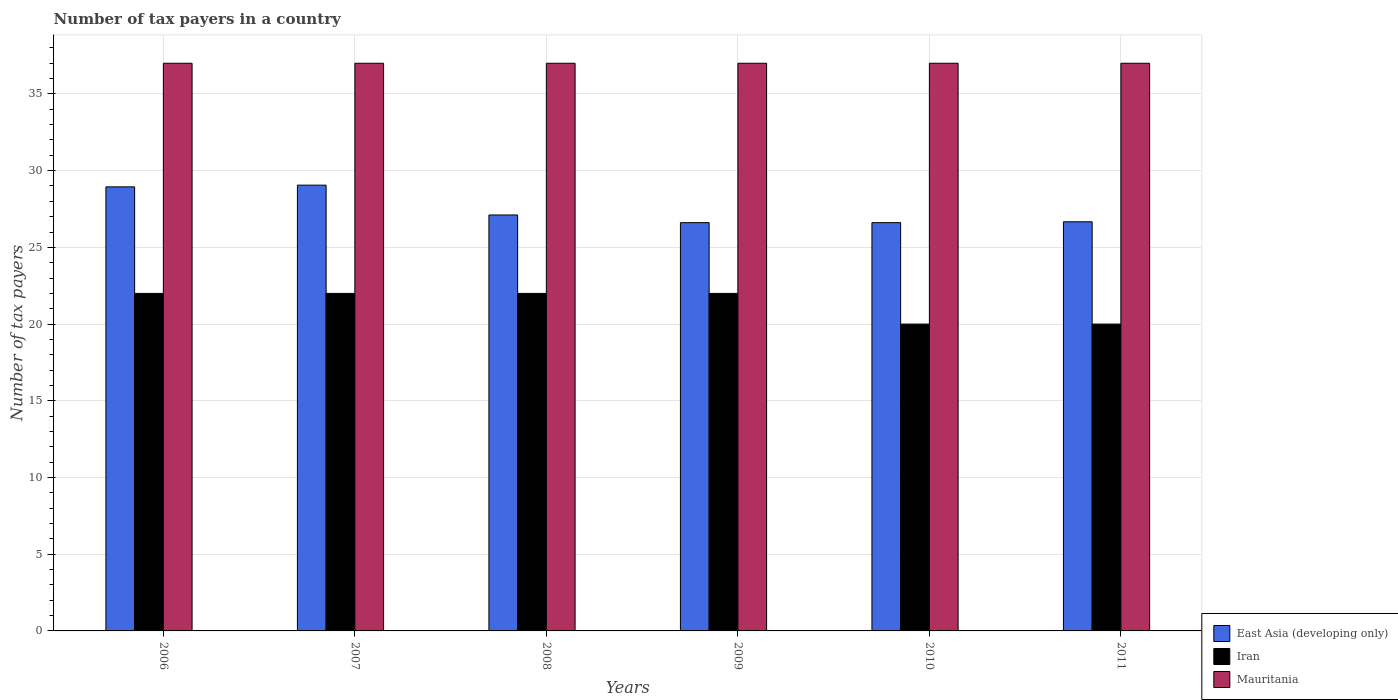How many groups of bars are there?
Ensure brevity in your answer.  6. How many bars are there on the 6th tick from the left?
Your answer should be compact. 3. How many bars are there on the 1st tick from the right?
Keep it short and to the point. 3. What is the label of the 1st group of bars from the left?
Your answer should be very brief. 2006. In how many cases, is the number of bars for a given year not equal to the number of legend labels?
Ensure brevity in your answer.  0. What is the number of tax payers in in Mauritania in 2006?
Offer a very short reply. 37. Across all years, what is the maximum number of tax payers in in East Asia (developing only)?
Offer a very short reply. 29.06. Across all years, what is the minimum number of tax payers in in Mauritania?
Your response must be concise. 37. In which year was the number of tax payers in in Mauritania minimum?
Make the answer very short. 2006. What is the total number of tax payers in in Mauritania in the graph?
Offer a very short reply. 222. What is the difference between the number of tax payers in in Iran in 2006 and that in 2010?
Provide a short and direct response. 2. What is the difference between the number of tax payers in in Iran in 2007 and the number of tax payers in in East Asia (developing only) in 2010?
Offer a terse response. -4.61. What is the average number of tax payers in in East Asia (developing only) per year?
Offer a terse response. 27.5. In the year 2006, what is the difference between the number of tax payers in in Iran and number of tax payers in in East Asia (developing only)?
Your answer should be very brief. -6.94. In how many years, is the number of tax payers in in Mauritania greater than 3?
Your response must be concise. 6. What is the ratio of the number of tax payers in in Mauritania in 2006 to that in 2011?
Your answer should be very brief. 1. Is the number of tax payers in in Mauritania in 2006 less than that in 2009?
Ensure brevity in your answer.  No. Is the difference between the number of tax payers in in Iran in 2009 and 2011 greater than the difference between the number of tax payers in in East Asia (developing only) in 2009 and 2011?
Provide a short and direct response. Yes. What is the difference between the highest and the second highest number of tax payers in in Iran?
Your answer should be very brief. 0. What is the difference between the highest and the lowest number of tax payers in in East Asia (developing only)?
Provide a succinct answer. 2.44. In how many years, is the number of tax payers in in Mauritania greater than the average number of tax payers in in Mauritania taken over all years?
Provide a short and direct response. 0. Is the sum of the number of tax payers in in East Asia (developing only) in 2006 and 2010 greater than the maximum number of tax payers in in Mauritania across all years?
Ensure brevity in your answer.  Yes. What does the 1st bar from the left in 2007 represents?
Offer a very short reply. East Asia (developing only). What does the 1st bar from the right in 2011 represents?
Give a very brief answer. Mauritania. Is it the case that in every year, the sum of the number of tax payers in in Iran and number of tax payers in in Mauritania is greater than the number of tax payers in in East Asia (developing only)?
Provide a short and direct response. Yes. How many bars are there?
Your answer should be compact. 18. What is the difference between two consecutive major ticks on the Y-axis?
Ensure brevity in your answer.  5. Does the graph contain any zero values?
Give a very brief answer. No. How are the legend labels stacked?
Ensure brevity in your answer.  Vertical. What is the title of the graph?
Ensure brevity in your answer.  Number of tax payers in a country. Does "Grenada" appear as one of the legend labels in the graph?
Your answer should be compact. No. What is the label or title of the X-axis?
Make the answer very short. Years. What is the label or title of the Y-axis?
Make the answer very short. Number of tax payers. What is the Number of tax payers in East Asia (developing only) in 2006?
Give a very brief answer. 28.94. What is the Number of tax payers of East Asia (developing only) in 2007?
Your response must be concise. 29.06. What is the Number of tax payers in Iran in 2007?
Offer a very short reply. 22. What is the Number of tax payers of Mauritania in 2007?
Offer a very short reply. 37. What is the Number of tax payers of East Asia (developing only) in 2008?
Keep it short and to the point. 27.11. What is the Number of tax payers in Mauritania in 2008?
Your answer should be very brief. 37. What is the Number of tax payers of East Asia (developing only) in 2009?
Provide a short and direct response. 26.61. What is the Number of tax payers in Iran in 2009?
Offer a very short reply. 22. What is the Number of tax payers of East Asia (developing only) in 2010?
Your answer should be very brief. 26.61. What is the Number of tax payers of East Asia (developing only) in 2011?
Offer a terse response. 26.67. What is the Number of tax payers of Mauritania in 2011?
Keep it short and to the point. 37. Across all years, what is the maximum Number of tax payers in East Asia (developing only)?
Provide a short and direct response. 29.06. Across all years, what is the minimum Number of tax payers in East Asia (developing only)?
Ensure brevity in your answer.  26.61. Across all years, what is the minimum Number of tax payers in Iran?
Ensure brevity in your answer.  20. Across all years, what is the minimum Number of tax payers of Mauritania?
Provide a succinct answer. 37. What is the total Number of tax payers of East Asia (developing only) in the graph?
Your answer should be compact. 165. What is the total Number of tax payers of Iran in the graph?
Offer a very short reply. 128. What is the total Number of tax payers of Mauritania in the graph?
Offer a terse response. 222. What is the difference between the Number of tax payers in East Asia (developing only) in 2006 and that in 2007?
Your response must be concise. -0.11. What is the difference between the Number of tax payers in Mauritania in 2006 and that in 2007?
Give a very brief answer. 0. What is the difference between the Number of tax payers of East Asia (developing only) in 2006 and that in 2008?
Ensure brevity in your answer.  1.83. What is the difference between the Number of tax payers of Iran in 2006 and that in 2008?
Make the answer very short. 0. What is the difference between the Number of tax payers in Mauritania in 2006 and that in 2008?
Offer a terse response. 0. What is the difference between the Number of tax payers of East Asia (developing only) in 2006 and that in 2009?
Offer a very short reply. 2.33. What is the difference between the Number of tax payers in Mauritania in 2006 and that in 2009?
Offer a terse response. 0. What is the difference between the Number of tax payers in East Asia (developing only) in 2006 and that in 2010?
Keep it short and to the point. 2.33. What is the difference between the Number of tax payers in East Asia (developing only) in 2006 and that in 2011?
Provide a succinct answer. 2.28. What is the difference between the Number of tax payers of East Asia (developing only) in 2007 and that in 2008?
Your response must be concise. 1.94. What is the difference between the Number of tax payers of Iran in 2007 and that in 2008?
Make the answer very short. 0. What is the difference between the Number of tax payers in East Asia (developing only) in 2007 and that in 2009?
Give a very brief answer. 2.44. What is the difference between the Number of tax payers in Iran in 2007 and that in 2009?
Your response must be concise. 0. What is the difference between the Number of tax payers in East Asia (developing only) in 2007 and that in 2010?
Provide a short and direct response. 2.44. What is the difference between the Number of tax payers of Iran in 2007 and that in 2010?
Your answer should be very brief. 2. What is the difference between the Number of tax payers in Mauritania in 2007 and that in 2010?
Keep it short and to the point. 0. What is the difference between the Number of tax payers in East Asia (developing only) in 2007 and that in 2011?
Provide a short and direct response. 2.39. What is the difference between the Number of tax payers in Mauritania in 2008 and that in 2009?
Your answer should be compact. 0. What is the difference between the Number of tax payers of East Asia (developing only) in 2008 and that in 2010?
Offer a very short reply. 0.5. What is the difference between the Number of tax payers of Mauritania in 2008 and that in 2010?
Your answer should be compact. 0. What is the difference between the Number of tax payers of East Asia (developing only) in 2008 and that in 2011?
Offer a terse response. 0.44. What is the difference between the Number of tax payers of Iran in 2008 and that in 2011?
Your answer should be compact. 2. What is the difference between the Number of tax payers of Mauritania in 2008 and that in 2011?
Keep it short and to the point. 0. What is the difference between the Number of tax payers in East Asia (developing only) in 2009 and that in 2011?
Keep it short and to the point. -0.06. What is the difference between the Number of tax payers of Iran in 2009 and that in 2011?
Provide a succinct answer. 2. What is the difference between the Number of tax payers of East Asia (developing only) in 2010 and that in 2011?
Make the answer very short. -0.06. What is the difference between the Number of tax payers in Iran in 2010 and that in 2011?
Your answer should be very brief. 0. What is the difference between the Number of tax payers of East Asia (developing only) in 2006 and the Number of tax payers of Iran in 2007?
Provide a succinct answer. 6.94. What is the difference between the Number of tax payers in East Asia (developing only) in 2006 and the Number of tax payers in Mauritania in 2007?
Give a very brief answer. -8.06. What is the difference between the Number of tax payers in East Asia (developing only) in 2006 and the Number of tax payers in Iran in 2008?
Offer a very short reply. 6.94. What is the difference between the Number of tax payers of East Asia (developing only) in 2006 and the Number of tax payers of Mauritania in 2008?
Ensure brevity in your answer.  -8.06. What is the difference between the Number of tax payers of Iran in 2006 and the Number of tax payers of Mauritania in 2008?
Give a very brief answer. -15. What is the difference between the Number of tax payers in East Asia (developing only) in 2006 and the Number of tax payers in Iran in 2009?
Your answer should be compact. 6.94. What is the difference between the Number of tax payers of East Asia (developing only) in 2006 and the Number of tax payers of Mauritania in 2009?
Give a very brief answer. -8.06. What is the difference between the Number of tax payers of Iran in 2006 and the Number of tax payers of Mauritania in 2009?
Keep it short and to the point. -15. What is the difference between the Number of tax payers of East Asia (developing only) in 2006 and the Number of tax payers of Iran in 2010?
Provide a succinct answer. 8.94. What is the difference between the Number of tax payers of East Asia (developing only) in 2006 and the Number of tax payers of Mauritania in 2010?
Offer a very short reply. -8.06. What is the difference between the Number of tax payers in Iran in 2006 and the Number of tax payers in Mauritania in 2010?
Give a very brief answer. -15. What is the difference between the Number of tax payers of East Asia (developing only) in 2006 and the Number of tax payers of Iran in 2011?
Your answer should be very brief. 8.94. What is the difference between the Number of tax payers in East Asia (developing only) in 2006 and the Number of tax payers in Mauritania in 2011?
Give a very brief answer. -8.06. What is the difference between the Number of tax payers of East Asia (developing only) in 2007 and the Number of tax payers of Iran in 2008?
Your answer should be very brief. 7.06. What is the difference between the Number of tax payers of East Asia (developing only) in 2007 and the Number of tax payers of Mauritania in 2008?
Make the answer very short. -7.94. What is the difference between the Number of tax payers of Iran in 2007 and the Number of tax payers of Mauritania in 2008?
Ensure brevity in your answer.  -15. What is the difference between the Number of tax payers in East Asia (developing only) in 2007 and the Number of tax payers in Iran in 2009?
Provide a short and direct response. 7.06. What is the difference between the Number of tax payers of East Asia (developing only) in 2007 and the Number of tax payers of Mauritania in 2009?
Ensure brevity in your answer.  -7.94. What is the difference between the Number of tax payers of Iran in 2007 and the Number of tax payers of Mauritania in 2009?
Offer a terse response. -15. What is the difference between the Number of tax payers of East Asia (developing only) in 2007 and the Number of tax payers of Iran in 2010?
Your response must be concise. 9.06. What is the difference between the Number of tax payers of East Asia (developing only) in 2007 and the Number of tax payers of Mauritania in 2010?
Provide a short and direct response. -7.94. What is the difference between the Number of tax payers in Iran in 2007 and the Number of tax payers in Mauritania in 2010?
Make the answer very short. -15. What is the difference between the Number of tax payers of East Asia (developing only) in 2007 and the Number of tax payers of Iran in 2011?
Make the answer very short. 9.06. What is the difference between the Number of tax payers in East Asia (developing only) in 2007 and the Number of tax payers in Mauritania in 2011?
Offer a very short reply. -7.94. What is the difference between the Number of tax payers of East Asia (developing only) in 2008 and the Number of tax payers of Iran in 2009?
Offer a very short reply. 5.11. What is the difference between the Number of tax payers in East Asia (developing only) in 2008 and the Number of tax payers in Mauritania in 2009?
Offer a very short reply. -9.89. What is the difference between the Number of tax payers of East Asia (developing only) in 2008 and the Number of tax payers of Iran in 2010?
Keep it short and to the point. 7.11. What is the difference between the Number of tax payers of East Asia (developing only) in 2008 and the Number of tax payers of Mauritania in 2010?
Your answer should be very brief. -9.89. What is the difference between the Number of tax payers in Iran in 2008 and the Number of tax payers in Mauritania in 2010?
Give a very brief answer. -15. What is the difference between the Number of tax payers in East Asia (developing only) in 2008 and the Number of tax payers in Iran in 2011?
Provide a succinct answer. 7.11. What is the difference between the Number of tax payers in East Asia (developing only) in 2008 and the Number of tax payers in Mauritania in 2011?
Ensure brevity in your answer.  -9.89. What is the difference between the Number of tax payers in Iran in 2008 and the Number of tax payers in Mauritania in 2011?
Provide a short and direct response. -15. What is the difference between the Number of tax payers of East Asia (developing only) in 2009 and the Number of tax payers of Iran in 2010?
Provide a succinct answer. 6.61. What is the difference between the Number of tax payers in East Asia (developing only) in 2009 and the Number of tax payers in Mauritania in 2010?
Give a very brief answer. -10.39. What is the difference between the Number of tax payers in Iran in 2009 and the Number of tax payers in Mauritania in 2010?
Keep it short and to the point. -15. What is the difference between the Number of tax payers of East Asia (developing only) in 2009 and the Number of tax payers of Iran in 2011?
Give a very brief answer. 6.61. What is the difference between the Number of tax payers of East Asia (developing only) in 2009 and the Number of tax payers of Mauritania in 2011?
Make the answer very short. -10.39. What is the difference between the Number of tax payers of Iran in 2009 and the Number of tax payers of Mauritania in 2011?
Your answer should be very brief. -15. What is the difference between the Number of tax payers in East Asia (developing only) in 2010 and the Number of tax payers in Iran in 2011?
Give a very brief answer. 6.61. What is the difference between the Number of tax payers in East Asia (developing only) in 2010 and the Number of tax payers in Mauritania in 2011?
Ensure brevity in your answer.  -10.39. What is the average Number of tax payers of Iran per year?
Your answer should be very brief. 21.33. What is the average Number of tax payers of Mauritania per year?
Provide a succinct answer. 37. In the year 2006, what is the difference between the Number of tax payers of East Asia (developing only) and Number of tax payers of Iran?
Make the answer very short. 6.94. In the year 2006, what is the difference between the Number of tax payers in East Asia (developing only) and Number of tax payers in Mauritania?
Give a very brief answer. -8.06. In the year 2006, what is the difference between the Number of tax payers of Iran and Number of tax payers of Mauritania?
Offer a very short reply. -15. In the year 2007, what is the difference between the Number of tax payers in East Asia (developing only) and Number of tax payers in Iran?
Keep it short and to the point. 7.06. In the year 2007, what is the difference between the Number of tax payers of East Asia (developing only) and Number of tax payers of Mauritania?
Offer a terse response. -7.94. In the year 2008, what is the difference between the Number of tax payers of East Asia (developing only) and Number of tax payers of Iran?
Offer a very short reply. 5.11. In the year 2008, what is the difference between the Number of tax payers in East Asia (developing only) and Number of tax payers in Mauritania?
Ensure brevity in your answer.  -9.89. In the year 2009, what is the difference between the Number of tax payers in East Asia (developing only) and Number of tax payers in Iran?
Your response must be concise. 4.61. In the year 2009, what is the difference between the Number of tax payers of East Asia (developing only) and Number of tax payers of Mauritania?
Offer a terse response. -10.39. In the year 2009, what is the difference between the Number of tax payers of Iran and Number of tax payers of Mauritania?
Make the answer very short. -15. In the year 2010, what is the difference between the Number of tax payers of East Asia (developing only) and Number of tax payers of Iran?
Keep it short and to the point. 6.61. In the year 2010, what is the difference between the Number of tax payers of East Asia (developing only) and Number of tax payers of Mauritania?
Your response must be concise. -10.39. In the year 2010, what is the difference between the Number of tax payers of Iran and Number of tax payers of Mauritania?
Keep it short and to the point. -17. In the year 2011, what is the difference between the Number of tax payers of East Asia (developing only) and Number of tax payers of Iran?
Ensure brevity in your answer.  6.67. In the year 2011, what is the difference between the Number of tax payers in East Asia (developing only) and Number of tax payers in Mauritania?
Provide a succinct answer. -10.33. In the year 2011, what is the difference between the Number of tax payers in Iran and Number of tax payers in Mauritania?
Offer a very short reply. -17. What is the ratio of the Number of tax payers in East Asia (developing only) in 2006 to that in 2007?
Offer a terse response. 1. What is the ratio of the Number of tax payers in Iran in 2006 to that in 2007?
Provide a short and direct response. 1. What is the ratio of the Number of tax payers in East Asia (developing only) in 2006 to that in 2008?
Provide a short and direct response. 1.07. What is the ratio of the Number of tax payers of Iran in 2006 to that in 2008?
Offer a very short reply. 1. What is the ratio of the Number of tax payers of Mauritania in 2006 to that in 2008?
Offer a very short reply. 1. What is the ratio of the Number of tax payers in East Asia (developing only) in 2006 to that in 2009?
Your answer should be compact. 1.09. What is the ratio of the Number of tax payers in Mauritania in 2006 to that in 2009?
Offer a very short reply. 1. What is the ratio of the Number of tax payers of East Asia (developing only) in 2006 to that in 2010?
Offer a very short reply. 1.09. What is the ratio of the Number of tax payers in Iran in 2006 to that in 2010?
Offer a terse response. 1.1. What is the ratio of the Number of tax payers in East Asia (developing only) in 2006 to that in 2011?
Offer a terse response. 1.09. What is the ratio of the Number of tax payers in Iran in 2006 to that in 2011?
Make the answer very short. 1.1. What is the ratio of the Number of tax payers of Mauritania in 2006 to that in 2011?
Keep it short and to the point. 1. What is the ratio of the Number of tax payers in East Asia (developing only) in 2007 to that in 2008?
Give a very brief answer. 1.07. What is the ratio of the Number of tax payers of Iran in 2007 to that in 2008?
Give a very brief answer. 1. What is the ratio of the Number of tax payers of East Asia (developing only) in 2007 to that in 2009?
Offer a terse response. 1.09. What is the ratio of the Number of tax payers in Mauritania in 2007 to that in 2009?
Provide a succinct answer. 1. What is the ratio of the Number of tax payers in East Asia (developing only) in 2007 to that in 2010?
Keep it short and to the point. 1.09. What is the ratio of the Number of tax payers in Iran in 2007 to that in 2010?
Give a very brief answer. 1.1. What is the ratio of the Number of tax payers of East Asia (developing only) in 2007 to that in 2011?
Your response must be concise. 1.09. What is the ratio of the Number of tax payers in Iran in 2007 to that in 2011?
Ensure brevity in your answer.  1.1. What is the ratio of the Number of tax payers in East Asia (developing only) in 2008 to that in 2009?
Provide a short and direct response. 1.02. What is the ratio of the Number of tax payers of East Asia (developing only) in 2008 to that in 2010?
Make the answer very short. 1.02. What is the ratio of the Number of tax payers in Mauritania in 2008 to that in 2010?
Offer a terse response. 1. What is the ratio of the Number of tax payers of East Asia (developing only) in 2008 to that in 2011?
Provide a short and direct response. 1.02. What is the ratio of the Number of tax payers in Iran in 2008 to that in 2011?
Your answer should be very brief. 1.1. What is the ratio of the Number of tax payers of East Asia (developing only) in 2009 to that in 2010?
Provide a succinct answer. 1. What is the ratio of the Number of tax payers of Iran in 2009 to that in 2010?
Provide a short and direct response. 1.1. What is the ratio of the Number of tax payers of East Asia (developing only) in 2009 to that in 2011?
Offer a terse response. 1. What is the ratio of the Number of tax payers of East Asia (developing only) in 2010 to that in 2011?
Offer a very short reply. 1. What is the difference between the highest and the second highest Number of tax payers in Iran?
Your response must be concise. 0. What is the difference between the highest and the lowest Number of tax payers in East Asia (developing only)?
Provide a succinct answer. 2.44. 